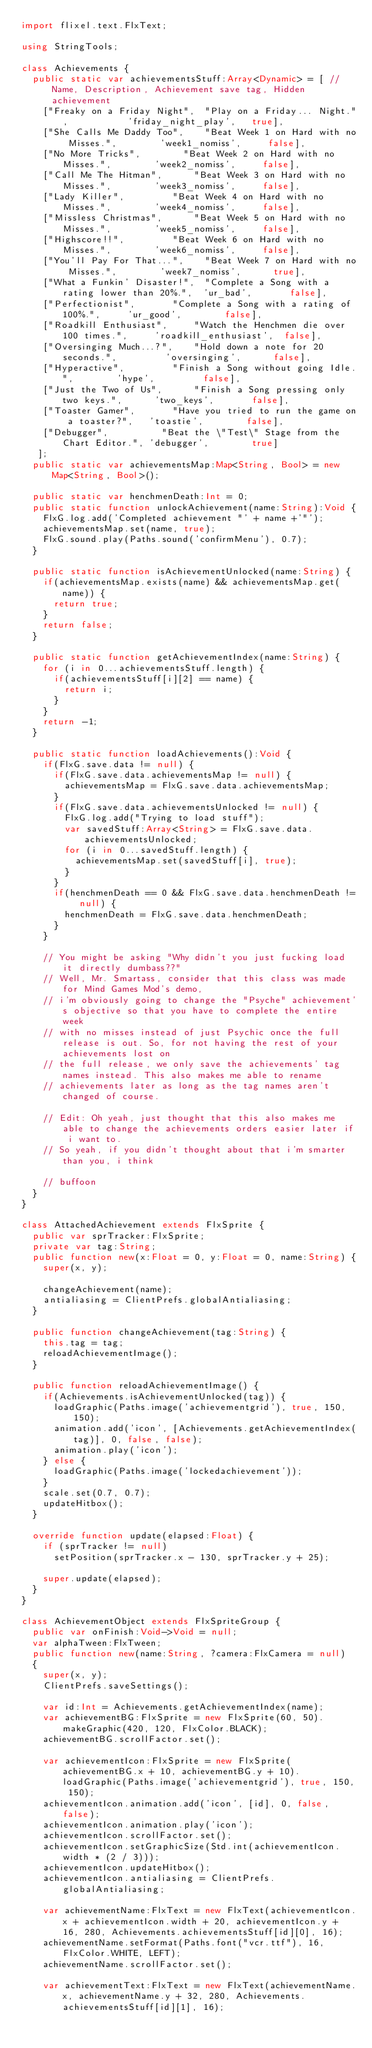<code> <loc_0><loc_0><loc_500><loc_500><_Haxe_>import flixel.text.FlxText;

using StringTools;

class Achievements {
	public static var achievementsStuff:Array<Dynamic> = [ //Name, Description, Achievement save tag, Hidden achievement
		["Freaky on a Friday Night",	"Play on a Friday... Night.",						'friday_night_play',	 true],
		["She Calls Me Daddy Too",		"Beat Week 1 on Hard with no Misses.",				'week1_nomiss',			false],
		["No More Tricks",				"Beat Week 2 on Hard with no Misses.",				'week2_nomiss',			false],
		["Call Me The Hitman",			"Beat Week 3 on Hard with no Misses.",				'week3_nomiss',			false],
		["Lady Killer",					"Beat Week 4 on Hard with no Misses.",				'week4_nomiss',			false],
		["Missless Christmas",			"Beat Week 5 on Hard with no Misses.",				'week5_nomiss',			false],
		["Highscore!!",					"Beat Week 6 on Hard with no Misses.",				'week6_nomiss',			false],
		["You'll Pay For That...",		"Beat Week 7 on Hard with no Misses.",				'week7_nomiss',			 true],
		["What a Funkin' Disaster!",	"Complete a Song with a rating lower than 20%.",	'ur_bad',				false],
		["Perfectionist",				"Complete a Song with a rating of 100%.",			'ur_good',				false],
		["Roadkill Enthusiast",			"Watch the Henchmen die over 100 times.",			'roadkill_enthusiast',	false],
		["Oversinging Much...?",		"Hold down a note for 20 seconds.",					'oversinging',			false],
		["Hyperactive",					"Finish a Song without going Idle.",				'hype',					false],
		["Just the Two of Us",			"Finish a Song pressing only two keys.",			'two_keys',				false],
		["Toaster Gamer",				"Have you tried to run the game on a toaster?",		'toastie',				false],
		["Debugger",					"Beat the \"Test\" Stage from the Chart Editor.",	'debugger',				 true]
   ];
	public static var achievementsMap:Map<String, Bool> = new Map<String, Bool>();

	public static var henchmenDeath:Int = 0;
	public static function unlockAchievement(name:String):Void {
		FlxG.log.add('Completed achievement "' + name +'"');
		achievementsMap.set(name, true);
		FlxG.sound.play(Paths.sound('confirmMenu'), 0.7);
	}

	public static function isAchievementUnlocked(name:String) {
		if(achievementsMap.exists(name) && achievementsMap.get(name)) {
			return true;
		}
		return false;
	}

	public static function getAchievementIndex(name:String) {
		for (i in 0...achievementsStuff.length) {
			if(achievementsStuff[i][2] == name) {
				return i;
			}
		}
		return -1;
	}

	public static function loadAchievements():Void {
		if(FlxG.save.data != null) {
			if(FlxG.save.data.achievementsMap != null) {
				achievementsMap = FlxG.save.data.achievementsMap;
			}
			if(FlxG.save.data.achievementsUnlocked != null) {
				FlxG.log.add("Trying to load stuff");
				var savedStuff:Array<String> = FlxG.save.data.achievementsUnlocked;
				for (i in 0...savedStuff.length) {
					achievementsMap.set(savedStuff[i], true);
				}
			}
			if(henchmenDeath == 0 && FlxG.save.data.henchmenDeath != null) {
				henchmenDeath = FlxG.save.data.henchmenDeath;
			}
		}

		// You might be asking "Why didn't you just fucking load it directly dumbass??"
		// Well, Mr. Smartass, consider that this class was made for Mind Games Mod's demo,
		// i'm obviously going to change the "Psyche" achievement's objective so that you have to complete the entire week
		// with no misses instead of just Psychic once the full release is out. So, for not having the rest of your achievements lost on
		// the full release, we only save the achievements' tag names instead. This also makes me able to rename
		// achievements later as long as the tag names aren't changed of course.

		// Edit: Oh yeah, just thought that this also makes me able to change the achievements orders easier later if i want to.
		// So yeah, if you didn't thought about that i'm smarter than you, i think

		// buffoon
	}
}

class AttachedAchievement extends FlxSprite {
	public var sprTracker:FlxSprite;
	private var tag:String;
	public function new(x:Float = 0, y:Float = 0, name:String) {
		super(x, y);

		changeAchievement(name);
		antialiasing = ClientPrefs.globalAntialiasing;
	}

	public function changeAchievement(tag:String) {
		this.tag = tag;
		reloadAchievementImage();
	}

	public function reloadAchievementImage() {
		if(Achievements.isAchievementUnlocked(tag)) {
			loadGraphic(Paths.image('achievementgrid'), true, 150, 150);
			animation.add('icon', [Achievements.getAchievementIndex(tag)], 0, false, false);
			animation.play('icon');
		} else {
			loadGraphic(Paths.image('lockedachievement'));
		}
		scale.set(0.7, 0.7);
		updateHitbox();
	}

	override function update(elapsed:Float) {
		if (sprTracker != null)
			setPosition(sprTracker.x - 130, sprTracker.y + 25);

		super.update(elapsed);
	}
}

class AchievementObject extends FlxSpriteGroup {
	public var onFinish:Void->Void = null;
	var alphaTween:FlxTween;
	public function new(name:String, ?camera:FlxCamera = null)
	{
		super(x, y);
		ClientPrefs.saveSettings();

		var id:Int = Achievements.getAchievementIndex(name);
		var achievementBG:FlxSprite = new FlxSprite(60, 50).makeGraphic(420, 120, FlxColor.BLACK);
		achievementBG.scrollFactor.set();

		var achievementIcon:FlxSprite = new FlxSprite(achievementBG.x + 10, achievementBG.y + 10).loadGraphic(Paths.image('achievementgrid'), true, 150, 150);
		achievementIcon.animation.add('icon', [id], 0, false, false);
		achievementIcon.animation.play('icon');
		achievementIcon.scrollFactor.set();
		achievementIcon.setGraphicSize(Std.int(achievementIcon.width * (2 / 3)));
		achievementIcon.updateHitbox();
		achievementIcon.antialiasing = ClientPrefs.globalAntialiasing;

		var achievementName:FlxText = new FlxText(achievementIcon.x + achievementIcon.width + 20, achievementIcon.y + 16, 280, Achievements.achievementsStuff[id][0], 16);
		achievementName.setFormat(Paths.font("vcr.ttf"), 16, FlxColor.WHITE, LEFT);
		achievementName.scrollFactor.set();

		var achievementText:FlxText = new FlxText(achievementName.x, achievementName.y + 32, 280, Achievements.achievementsStuff[id][1], 16);</code> 